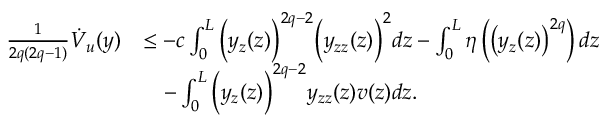Convert formula to latex. <formula><loc_0><loc_0><loc_500><loc_500>\begin{array} { r l } { \frac { 1 } { 2 q ( 2 q - 1 ) } \dot { V } _ { u } ( y ) } & { \leq - c \int _ { 0 } ^ { L } \left ( y _ { z } ( z ) \right ) ^ { 2 q - 2 } \left ( y _ { z z } ( z ) \right ) ^ { 2 } d z - \int _ { 0 } ^ { L } \eta \left ( \left ( y _ { z } ( z ) \right ) ^ { 2 q } \right ) d z } \\ & { \quad - \int _ { 0 } ^ { L } \left ( y _ { z } ( z ) \right ) ^ { 2 q - 2 } y _ { z z } ( z ) v ( z ) d z . } \end{array}</formula> 